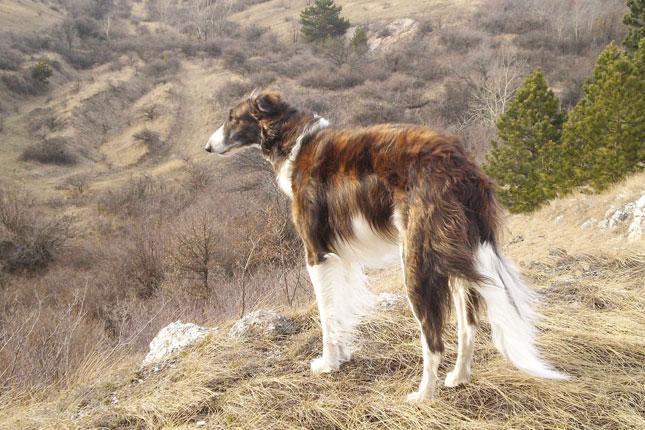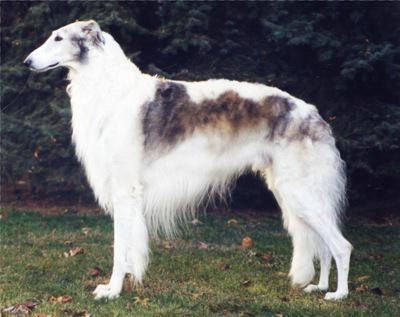The first image is the image on the left, the second image is the image on the right. Examine the images to the left and right. Is the description "There are two dogs" accurate? Answer yes or no. Yes. 